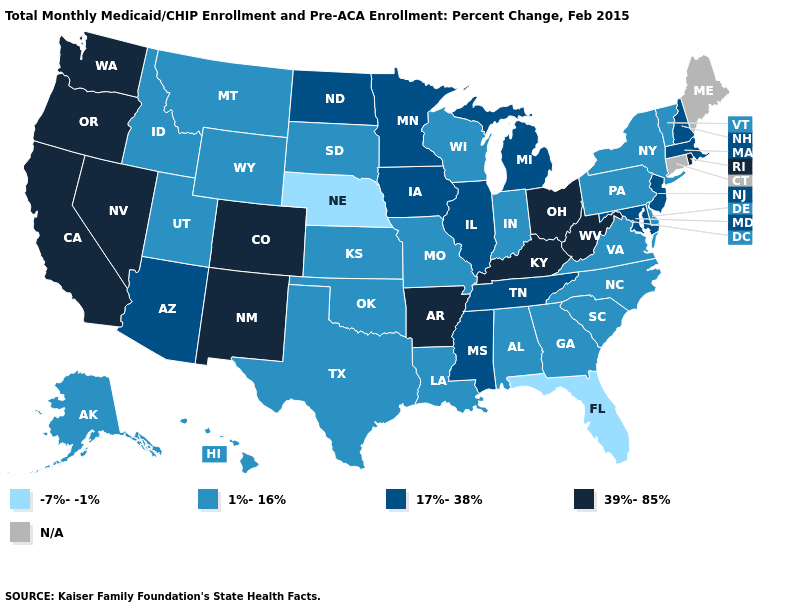Which states hav the highest value in the MidWest?
Quick response, please. Ohio. What is the lowest value in the USA?
Quick response, please. -7%--1%. Name the states that have a value in the range N/A?
Quick response, please. Connecticut, Maine. Among the states that border Georgia , which have the lowest value?
Write a very short answer. Florida. What is the value of California?
Concise answer only. 39%-85%. What is the value of Virginia?
Give a very brief answer. 1%-16%. What is the value of Wisconsin?
Write a very short answer. 1%-16%. What is the highest value in states that border Minnesota?
Be succinct. 17%-38%. Does Vermont have the lowest value in the USA?
Keep it brief. No. What is the value of Idaho?
Concise answer only. 1%-16%. Which states have the lowest value in the USA?
Write a very short answer. Florida, Nebraska. Name the states that have a value in the range 17%-38%?
Quick response, please. Arizona, Illinois, Iowa, Maryland, Massachusetts, Michigan, Minnesota, Mississippi, New Hampshire, New Jersey, North Dakota, Tennessee. What is the value of Michigan?
Concise answer only. 17%-38%. What is the value of Ohio?
Write a very short answer. 39%-85%. How many symbols are there in the legend?
Give a very brief answer. 5. 